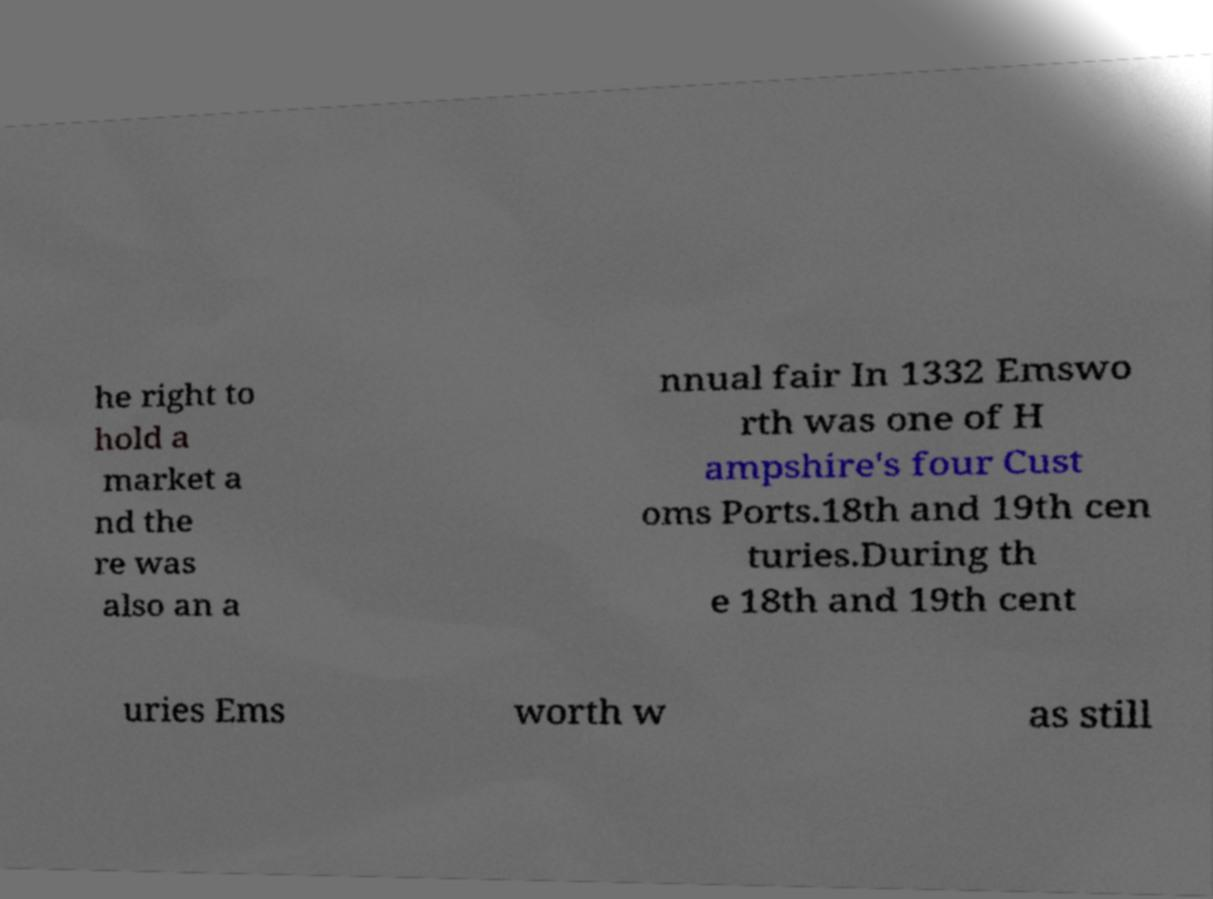What messages or text are displayed in this image? I need them in a readable, typed format. he right to hold a market a nd the re was also an a nnual fair In 1332 Emswo rth was one of H ampshire's four Cust oms Ports.18th and 19th cen turies.During th e 18th and 19th cent uries Ems worth w as still 